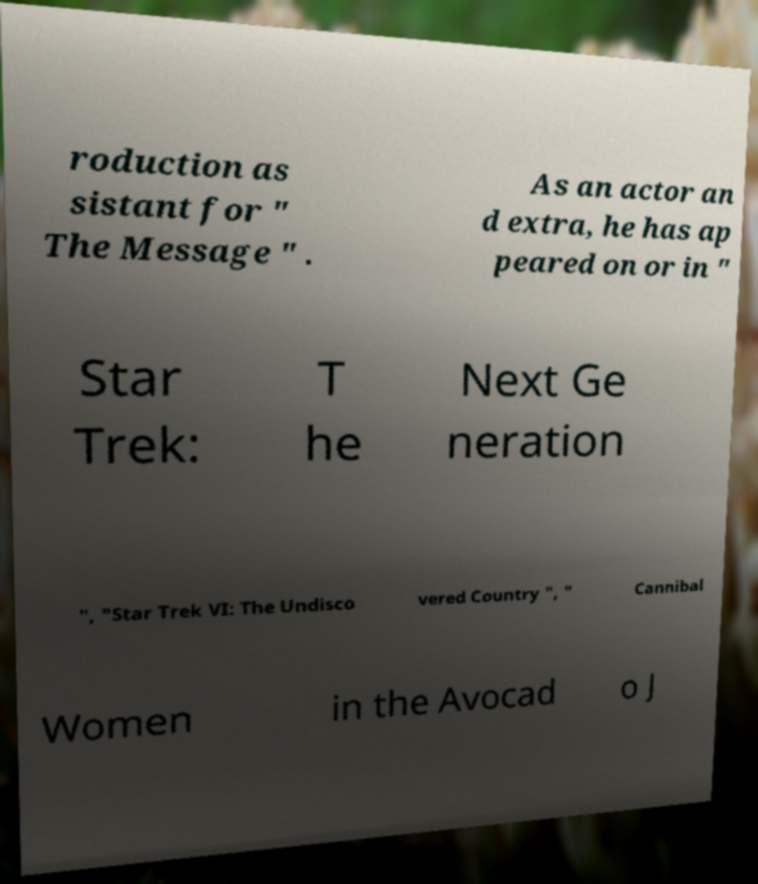Can you accurately transcribe the text from the provided image for me? roduction as sistant for " The Message " . As an actor an d extra, he has ap peared on or in " Star Trek: T he Next Ge neration ", "Star Trek VI: The Undisco vered Country ", " Cannibal Women in the Avocad o J 